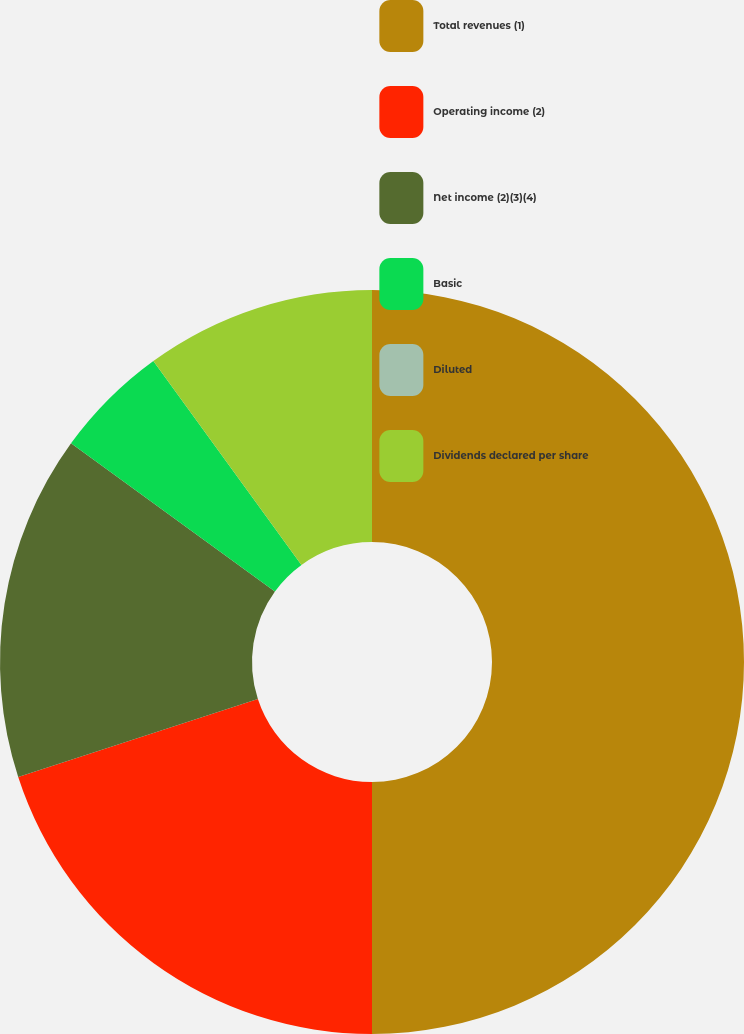Convert chart to OTSL. <chart><loc_0><loc_0><loc_500><loc_500><pie_chart><fcel>Total revenues (1)<fcel>Operating income (2)<fcel>Net income (2)(3)(4)<fcel>Basic<fcel>Diluted<fcel>Dividends declared per share<nl><fcel>50.0%<fcel>20.0%<fcel>15.0%<fcel>5.0%<fcel>0.0%<fcel>10.0%<nl></chart> 